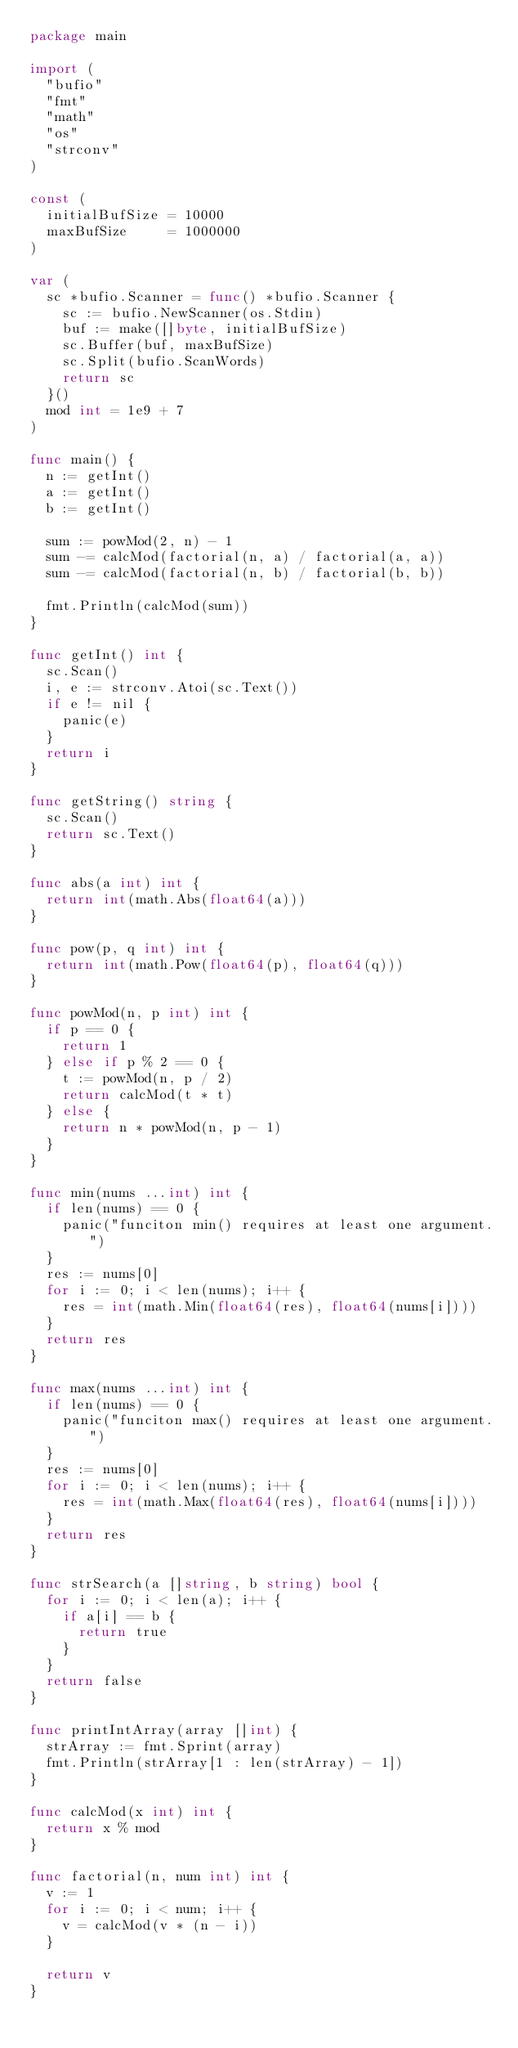Convert code to text. <code><loc_0><loc_0><loc_500><loc_500><_Go_>package main

import (
	"bufio"
	"fmt"
	"math"
	"os"
	"strconv"
)

const (
	initialBufSize = 10000
	maxBufSize     = 1000000
)

var (
	sc *bufio.Scanner = func() *bufio.Scanner {
		sc := bufio.NewScanner(os.Stdin)
		buf := make([]byte, initialBufSize)
		sc.Buffer(buf, maxBufSize)
		sc.Split(bufio.ScanWords)
		return sc
	}()
	mod int = 1e9 + 7
)

func main() {
	n := getInt()
	a := getInt()
	b := getInt()

	sum := powMod(2, n) - 1
	sum -= calcMod(factorial(n, a) / factorial(a, a))
	sum -= calcMod(factorial(n, b) / factorial(b, b))

	fmt.Println(calcMod(sum))
}

func getInt() int {
	sc.Scan()
	i, e := strconv.Atoi(sc.Text())
	if e != nil {
		panic(e)
	}
	return i
}

func getString() string {
	sc.Scan()
	return sc.Text()
}

func abs(a int) int {
	return int(math.Abs(float64(a)))
}

func pow(p, q int) int {
	return int(math.Pow(float64(p), float64(q)))
}

func powMod(n, p int) int {
	if p == 0 {
		return 1
	} else if p % 2 == 0 {
		t := powMod(n, p / 2)
		return calcMod(t * t)
	} else {
		return n * powMod(n, p - 1)
	}
}

func min(nums ...int) int {
	if len(nums) == 0 {
		panic("funciton min() requires at least one argument.")
	}
	res := nums[0]
	for i := 0; i < len(nums); i++ {
		res = int(math.Min(float64(res), float64(nums[i])))
	}
	return res
}

func max(nums ...int) int {
	if len(nums) == 0 {
		panic("funciton max() requires at least one argument.")
	}
	res := nums[0]
	for i := 0; i < len(nums); i++ {
		res = int(math.Max(float64(res), float64(nums[i])))
	}
	return res
}

func strSearch(a []string, b string) bool {
	for i := 0; i < len(a); i++ {
		if a[i] == b {
			return true
		}
	}
	return false
}

func printIntArray(array []int) {
	strArray := fmt.Sprint(array)
	fmt.Println(strArray[1 : len(strArray) - 1])
}

func calcMod(x int) int {
	return x % mod
}

func factorial(n, num int) int {
	v := 1
	for i := 0; i < num; i++ {
		v = calcMod(v * (n - i))
	}

	return v
}
</code> 